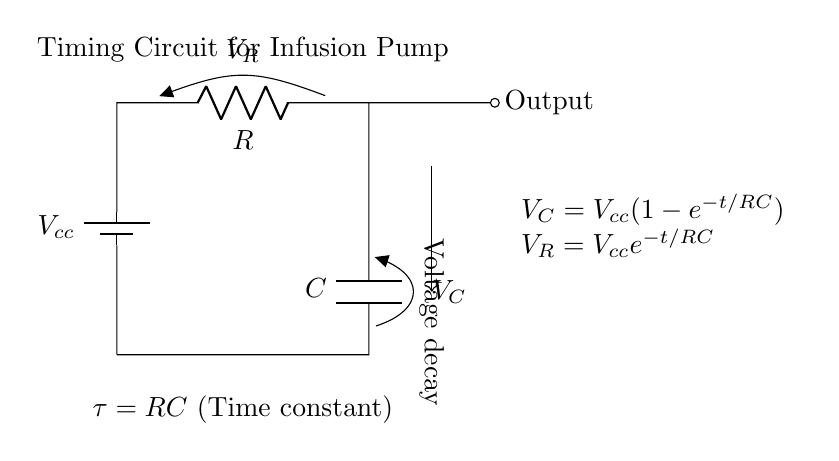What is the battery voltage in this circuit? The circuit shows a battery, denoted as \( V_{cc} \), which is labeled but not specified in value. In practice, this represents the power supply voltage connected to the circuit.
Answer: \( V_{cc} \) What component is connected in series with the resistor? In the circuit diagram, a capacitor labeled \( C \) is connected in series after the resistor \( R \). The series connection indicates that current flows through the resistor first, then to the capacitor.
Answer: Capacitor What does the time constant \( \tau \) represent? The time constant \( \tau = RC \) indicates the time it takes for the voltage across the capacitor to change significantly, specifically about 63.2 percent of its final value after a change in voltage. The product of resistance and capacitance determines how quickly the circuit responds to voltage changes.
Answer: \( RC \) What is the formula for the voltage across the capacitor? The formula shown in the circuit \( V_C = V_{cc}(1 - e^{-t/RC}) \) describes how the voltage across the capacitor increases over time. It reflects the exponential behavior of charging in an RC circuit where voltage approaches \( V_{cc} \) as time progresses.
Answer: \( V_C = V_{cc}(1 - e^{-t/RC}) \) Which component causes the voltage decay over time? The resistor \( R \) influences the voltage decay across the capacitor by controlling how fast the capacitor charges and discharges. The exponential decay character of \( V_R = V_{cc}e^{-t/RC} \) indicates the voltage across the resistor decreases as time increases.
Answer: Resistor At what time does the capacitor reach approximately 63.2 percent of \( V_{cc} \)? At the time equal to one time constant \( t = RC \), the capacitor reaches approximately 63.2 percent of \( V_{cc} \). This is a characteristic property of RC circuits, establishing a predictable timing behavior essential for infusion pump functionality.
Answer: \( RC \) 